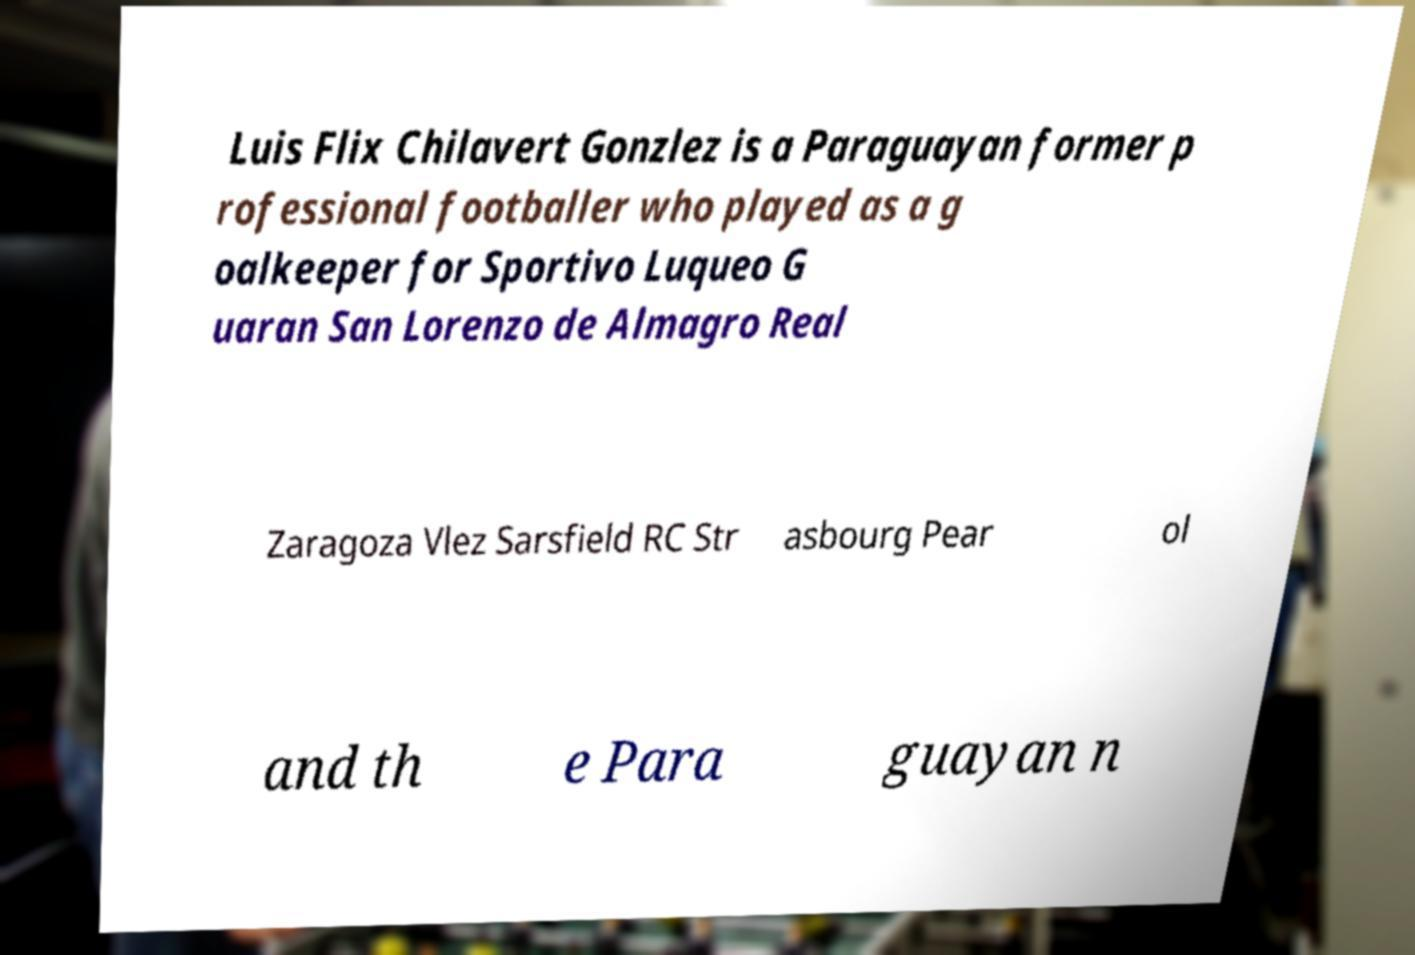Can you accurately transcribe the text from the provided image for me? Luis Flix Chilavert Gonzlez is a Paraguayan former p rofessional footballer who played as a g oalkeeper for Sportivo Luqueo G uaran San Lorenzo de Almagro Real Zaragoza Vlez Sarsfield RC Str asbourg Pear ol and th e Para guayan n 